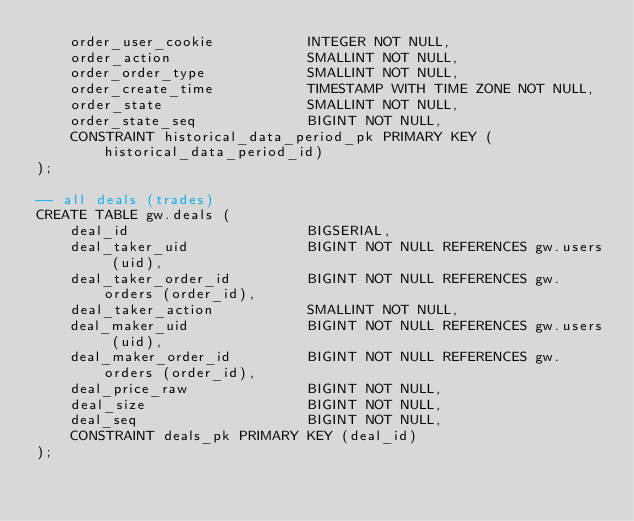<code> <loc_0><loc_0><loc_500><loc_500><_SQL_>    order_user_cookie           INTEGER NOT NULL,
    order_action                SMALLINT NOT NULL,
    order_order_type            SMALLINT NOT NULL,
    order_create_time           TIMESTAMP WITH TIME ZONE NOT NULL,
    order_state                 SMALLINT NOT NULL,
    order_state_seq             BIGINT NOT NULL,
    CONSTRAINT historical_data_period_pk PRIMARY KEY (historical_data_period_id)
);

-- all deals (trades)
CREATE TABLE gw.deals (
    deal_id                     BIGSERIAL,
    deal_taker_uid              BIGINT NOT NULL REFERENCES gw.users (uid),
    deal_taker_order_id         BIGINT NOT NULL REFERENCES gw.orders (order_id),
    deal_taker_action           SMALLINT NOT NULL,
    deal_maker_uid              BIGINT NOT NULL REFERENCES gw.users (uid),
    deal_maker_order_id         BIGINT NOT NULL REFERENCES gw.orders (order_id),
    deal_price_raw              BIGINT NOT NULL,
    deal_size                   BIGINT NOT NULL,
    deal_seq                    BIGINT NOT NULL,
    CONSTRAINT deals_pk PRIMARY KEY (deal_id)
);
</code> 